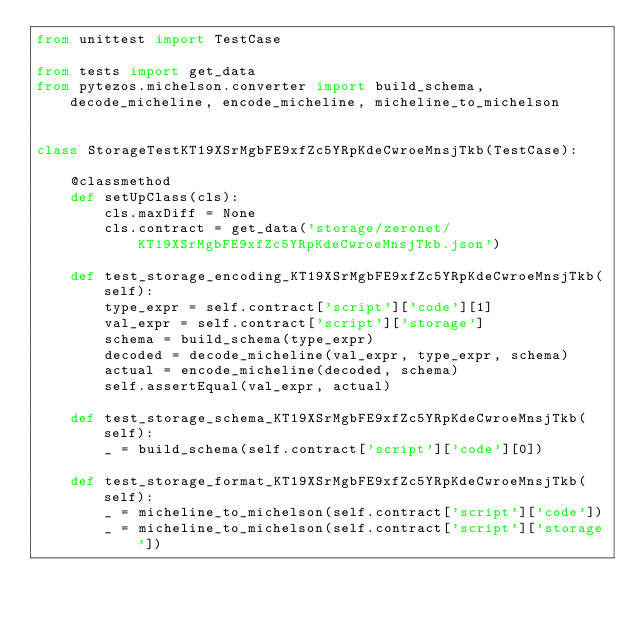Convert code to text. <code><loc_0><loc_0><loc_500><loc_500><_Python_>from unittest import TestCase

from tests import get_data
from pytezos.michelson.converter import build_schema, decode_micheline, encode_micheline, micheline_to_michelson


class StorageTestKT19XSrMgbFE9xfZc5YRpKdeCwroeMnsjTkb(TestCase):

    @classmethod
    def setUpClass(cls):
        cls.maxDiff = None
        cls.contract = get_data('storage/zeronet/KT19XSrMgbFE9xfZc5YRpKdeCwroeMnsjTkb.json')

    def test_storage_encoding_KT19XSrMgbFE9xfZc5YRpKdeCwroeMnsjTkb(self):
        type_expr = self.contract['script']['code'][1]
        val_expr = self.contract['script']['storage']
        schema = build_schema(type_expr)
        decoded = decode_micheline(val_expr, type_expr, schema)
        actual = encode_micheline(decoded, schema)
        self.assertEqual(val_expr, actual)

    def test_storage_schema_KT19XSrMgbFE9xfZc5YRpKdeCwroeMnsjTkb(self):
        _ = build_schema(self.contract['script']['code'][0])

    def test_storage_format_KT19XSrMgbFE9xfZc5YRpKdeCwroeMnsjTkb(self):
        _ = micheline_to_michelson(self.contract['script']['code'])
        _ = micheline_to_michelson(self.contract['script']['storage'])
</code> 